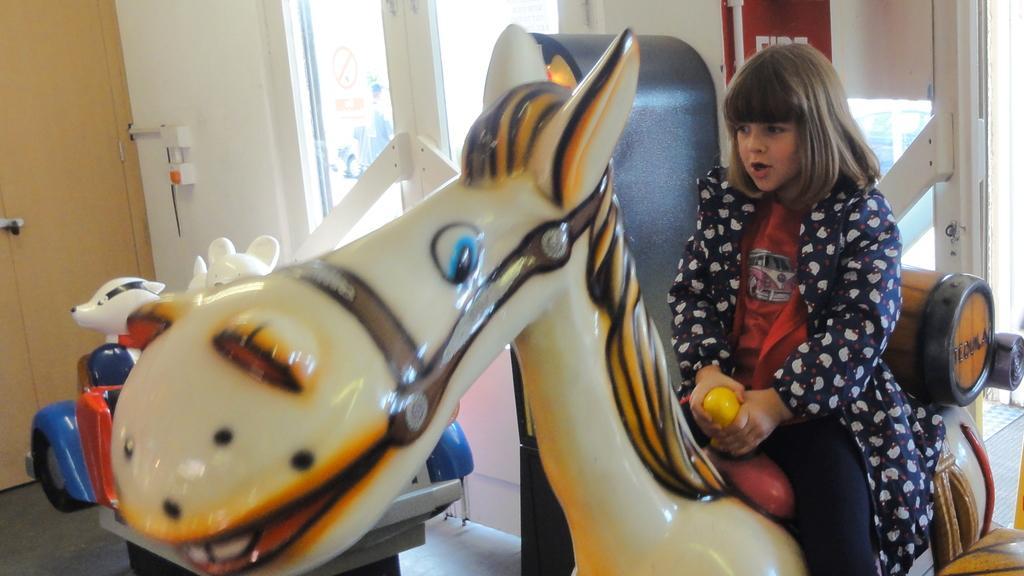Can you describe this image briefly? In this picture we can see a girl sitting on a toy animal, window, cupboard, wall and some objects. 